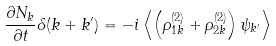<formula> <loc_0><loc_0><loc_500><loc_500>\frac { \partial N _ { k } } { \partial t } \delta ( k + k ^ { \prime } ) = - i \left < \left ( \rho _ { 1 k } ^ { ( 2 ) } + \rho _ { 2 k } ^ { ( 2 ) } \right ) \psi _ { k ^ { \prime } } \right ></formula> 